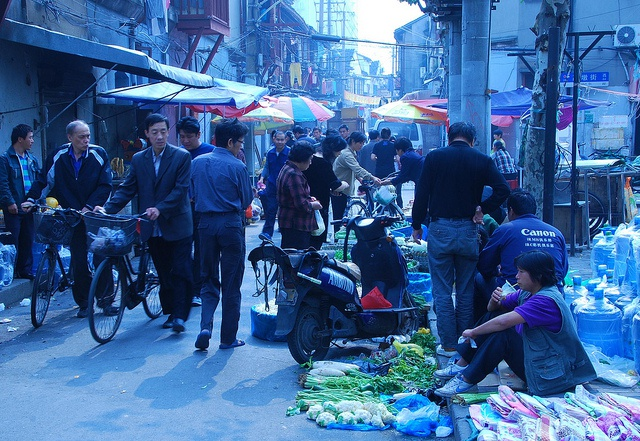Describe the objects in this image and their specific colors. I can see motorcycle in navy, black, and blue tones, people in navy, black, blue, and darkblue tones, people in navy, black, blue, and darkblue tones, people in navy, black, blue, and gray tones, and people in navy, black, and blue tones in this image. 